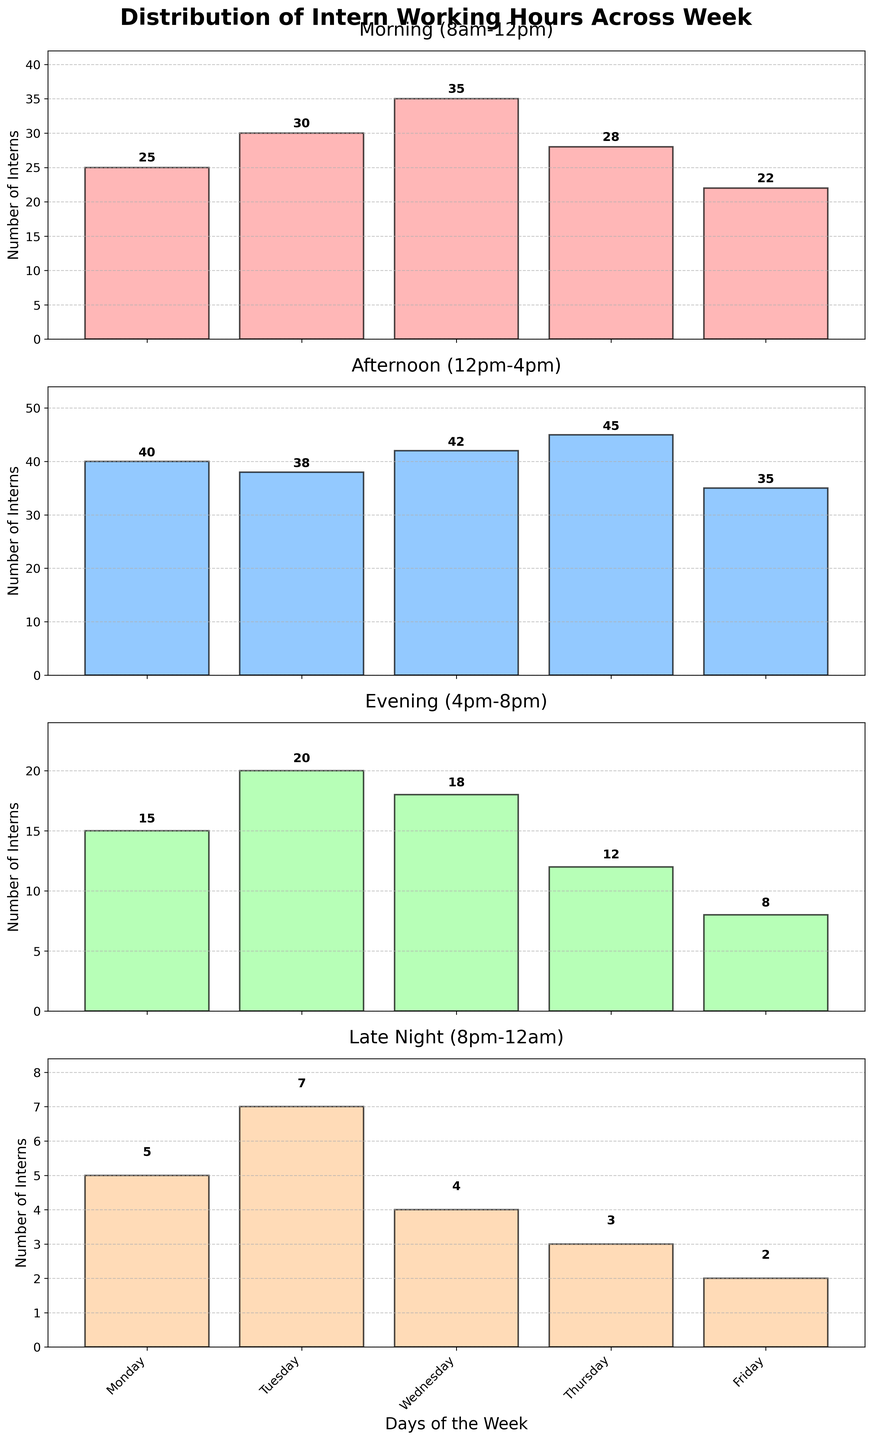What is the total number of interns working on Wednesday morning and afternoon? Add the number of interns working on Wednesday morning (35) and the number of interns working on Wednesday afternoon (42). The total is 35 + 42 = 77.
Answer: 77 Which day has the highest number of interns working in the late night slot (8pm-12am)? Compare the number of interns across all days for the late night slot (Monday=5, Tuesday=7, Wednesday=4, Thursday=3, Friday=2). Tuesday has the highest number of interns (7).
Answer: Tuesday How does the number of interns working on Friday afternoon compare to Thursday afternoon? Compare the values for Friday afternoon (35) and Thursday afternoon (45). 35 is less than 45.
Answer: Less Between Monday and Thursday, on which day do more interns work in the morning? Compare the number of interns working in the morning on Monday (25) and Thursday (28). Thursday has more interns (28).
Answer: Thursday What is the average number of interns working in the evening slot (4pm-8pm) for the entire week? Sum the number of interns working in the evening slot for all days (Monday=15, Tuesday=20, Wednesday=18, Thursday=12, Friday=8) and divide by the number of days (5). The total sum is 15 + 20 + 18 + 12 + 8 = 73, and the average is 73 / 5 = 14.6
Answer: 14.6 Which time slot has the most consistent number of interns throughout the week? Check the variability in the number of interns for each time slot. The values are: Morning (8am-12pm): [25, 30, 35, 28, 22], Afternoon (12pm-4pm): [40, 38, 42, 45, 35], Evening (4pm-8pm): [15, 20, 18, 12, 8], Late Night (8pm-12am): [5, 7, 4, 3, 2]. The morning slot has the smallest range (35-22=13).
Answer: Morning What's the difference in the number of interns working between the morning and evening slots on Wednesday? Subtract the number of interns in the evening slot (18) from the number of interns in the morning slot (35) on Wednesday. The difference is 35 - 18 = 17.
Answer: 17 On which day is the attendance of interns the lowest in the afternoon slot (12pm-4pm)? Compare the number of interns across all days for the afternoon slot (Monday=40, Tuesday=38, Wednesday=42, Thursday=45, Friday=35). Friday has the lowest number of interns (35).
Answer: Friday What is the total number of interns working on Thursdays across all time slots? Sum the number of interns working in each time slot on Thursday: Morning (28), Afternoon (45), Evening (12), and Late Night (3). Total is 28 + 45 + 12 + 3 = 88.
Answer: 88 